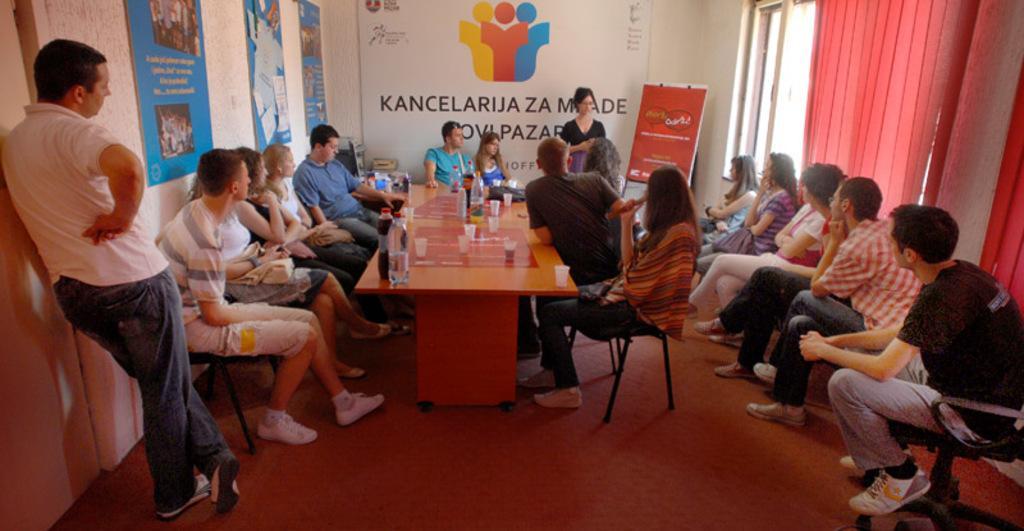In one or two sentences, can you explain what this image depicts? In this picture we can see some persons sitting on the chairs. This is the floor. There is a table, on the table there are bottles, and glasses. And here we can see a person leaning on to the wall. On the background we can see some hoardings. And this is the curtain and there is a window. 